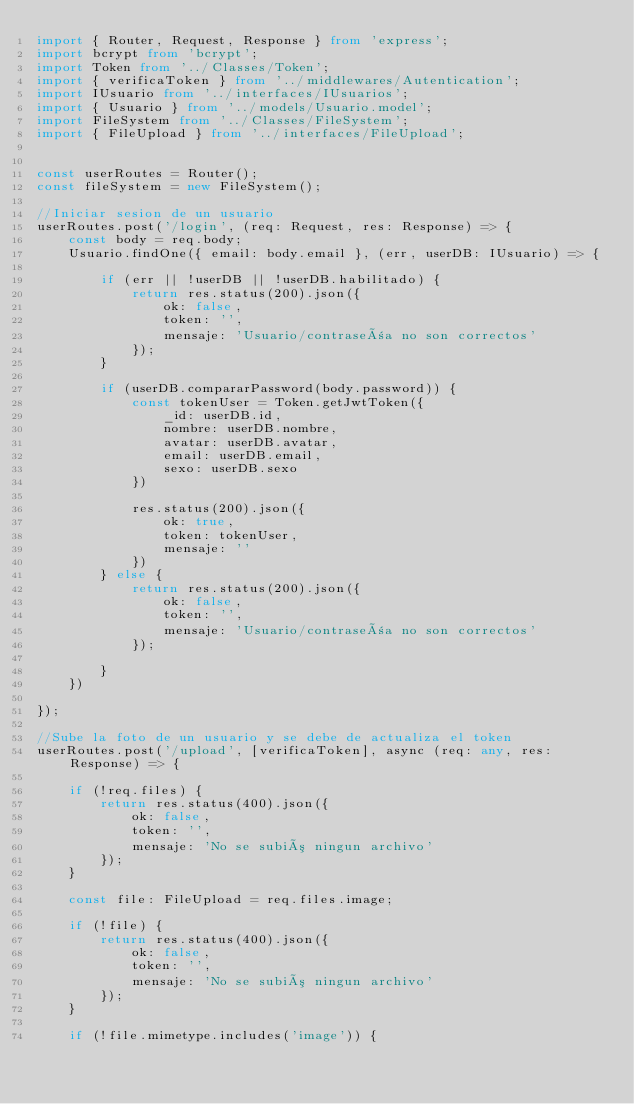Convert code to text. <code><loc_0><loc_0><loc_500><loc_500><_TypeScript_>import { Router, Request, Response } from 'express';
import bcrypt from 'bcrypt';
import Token from '../Classes/Token';
import { verificaToken } from '../middlewares/Autentication';
import IUsuario from '../interfaces/IUsuarios';
import { Usuario } from '../models/Usuario.model';
import FileSystem from '../Classes/FileSystem';
import { FileUpload } from '../interfaces/FileUpload';


const userRoutes = Router();
const fileSystem = new FileSystem();

//Iniciar sesion de un usuario
userRoutes.post('/login', (req: Request, res: Response) => {
    const body = req.body;
    Usuario.findOne({ email: body.email }, (err, userDB: IUsuario) => {

        if (err || !userDB || !userDB.habilitado) {
            return res.status(200).json({
                ok: false,
                token: '',
                mensaje: 'Usuario/contraseña no son correctos'
            });
        }

        if (userDB.compararPassword(body.password)) {
            const tokenUser = Token.getJwtToken({
                _id: userDB.id,
                nombre: userDB.nombre,
                avatar: userDB.avatar,
                email: userDB.email,
                sexo: userDB.sexo
            })

            res.status(200).json({
                ok: true,
                token: tokenUser,
                mensaje: ''
            })
        } else {
            return res.status(200).json({
                ok: false,
                token: '',
                mensaje: 'Usuario/contraseña no son correctos'
            });

        }
    })

});

//Sube la foto de un usuario y se debe de actualiza el token
userRoutes.post('/upload', [verificaToken], async (req: any, res: Response) => {

    if (!req.files) {
        return res.status(400).json({
            ok: false,
            token: '',
            mensaje: 'No se subió ningun archivo'
        });
    }

    const file: FileUpload = req.files.image;

    if (!file) {
        return res.status(400).json({
            ok: false,
            token: '',
            mensaje: 'No se subió ningun archivo'
        });
    }

    if (!file.mimetype.includes('image')) {</code> 